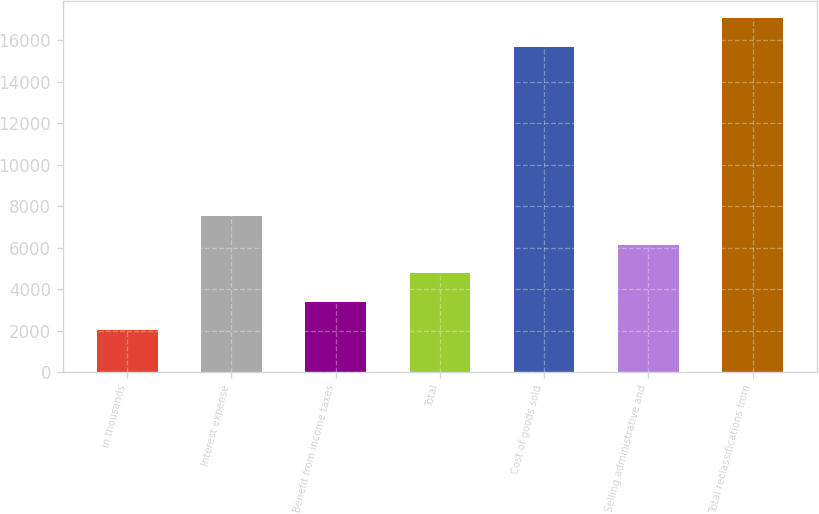<chart> <loc_0><loc_0><loc_500><loc_500><bar_chart><fcel>in thousands<fcel>Interest expense<fcel>Benefit from income taxes<fcel>Total<fcel>Cost of goods sold<fcel>Selling administrative and<fcel>Total reclassifications from<nl><fcel>2012<fcel>7519.6<fcel>3388.9<fcel>4765.8<fcel>15665<fcel>6142.7<fcel>17041.9<nl></chart> 